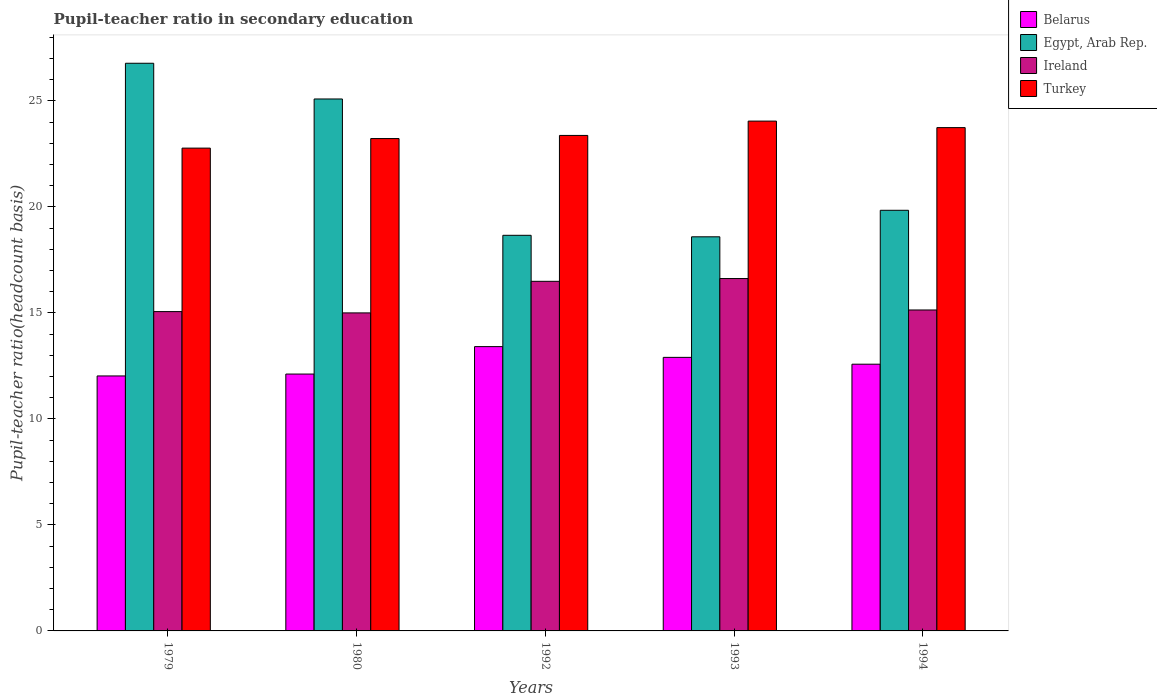How many different coloured bars are there?
Keep it short and to the point. 4. Are the number of bars per tick equal to the number of legend labels?
Your answer should be compact. Yes. Are the number of bars on each tick of the X-axis equal?
Your answer should be compact. Yes. How many bars are there on the 4th tick from the left?
Offer a very short reply. 4. How many bars are there on the 5th tick from the right?
Your response must be concise. 4. What is the label of the 1st group of bars from the left?
Provide a succinct answer. 1979. In how many cases, is the number of bars for a given year not equal to the number of legend labels?
Make the answer very short. 0. What is the pupil-teacher ratio in secondary education in Belarus in 1980?
Make the answer very short. 12.12. Across all years, what is the maximum pupil-teacher ratio in secondary education in Egypt, Arab Rep.?
Give a very brief answer. 26.78. Across all years, what is the minimum pupil-teacher ratio in secondary education in Belarus?
Offer a terse response. 12.03. In which year was the pupil-teacher ratio in secondary education in Turkey maximum?
Provide a short and direct response. 1993. In which year was the pupil-teacher ratio in secondary education in Belarus minimum?
Your answer should be very brief. 1979. What is the total pupil-teacher ratio in secondary education in Ireland in the graph?
Keep it short and to the point. 78.31. What is the difference between the pupil-teacher ratio in secondary education in Belarus in 1979 and that in 1994?
Offer a terse response. -0.55. What is the difference between the pupil-teacher ratio in secondary education in Belarus in 1992 and the pupil-teacher ratio in secondary education in Turkey in 1994?
Provide a succinct answer. -10.33. What is the average pupil-teacher ratio in secondary education in Ireland per year?
Provide a short and direct response. 15.66. In the year 1993, what is the difference between the pupil-teacher ratio in secondary education in Ireland and pupil-teacher ratio in secondary education in Belarus?
Give a very brief answer. 3.72. What is the ratio of the pupil-teacher ratio in secondary education in Ireland in 1979 to that in 1994?
Give a very brief answer. 0.99. Is the pupil-teacher ratio in secondary education in Belarus in 1980 less than that in 1994?
Keep it short and to the point. Yes. Is the difference between the pupil-teacher ratio in secondary education in Ireland in 1979 and 1992 greater than the difference between the pupil-teacher ratio in secondary education in Belarus in 1979 and 1992?
Your answer should be compact. No. What is the difference between the highest and the second highest pupil-teacher ratio in secondary education in Belarus?
Your answer should be compact. 0.51. What is the difference between the highest and the lowest pupil-teacher ratio in secondary education in Turkey?
Your answer should be compact. 1.27. Is it the case that in every year, the sum of the pupil-teacher ratio in secondary education in Belarus and pupil-teacher ratio in secondary education in Ireland is greater than the sum of pupil-teacher ratio in secondary education in Turkey and pupil-teacher ratio in secondary education in Egypt, Arab Rep.?
Give a very brief answer. Yes. What does the 2nd bar from the left in 1993 represents?
Provide a succinct answer. Egypt, Arab Rep. What does the 4th bar from the right in 1980 represents?
Provide a succinct answer. Belarus. How many bars are there?
Your response must be concise. 20. How many years are there in the graph?
Ensure brevity in your answer.  5. What is the difference between two consecutive major ticks on the Y-axis?
Your answer should be compact. 5. Does the graph contain any zero values?
Provide a succinct answer. No. Does the graph contain grids?
Your answer should be compact. No. Where does the legend appear in the graph?
Offer a very short reply. Top right. How many legend labels are there?
Ensure brevity in your answer.  4. How are the legend labels stacked?
Your answer should be compact. Vertical. What is the title of the graph?
Offer a very short reply. Pupil-teacher ratio in secondary education. Does "St. Martin (French part)" appear as one of the legend labels in the graph?
Offer a very short reply. No. What is the label or title of the Y-axis?
Your answer should be compact. Pupil-teacher ratio(headcount basis). What is the Pupil-teacher ratio(headcount basis) of Belarus in 1979?
Ensure brevity in your answer.  12.03. What is the Pupil-teacher ratio(headcount basis) of Egypt, Arab Rep. in 1979?
Make the answer very short. 26.78. What is the Pupil-teacher ratio(headcount basis) in Ireland in 1979?
Give a very brief answer. 15.06. What is the Pupil-teacher ratio(headcount basis) of Turkey in 1979?
Provide a short and direct response. 22.77. What is the Pupil-teacher ratio(headcount basis) in Belarus in 1980?
Your answer should be very brief. 12.12. What is the Pupil-teacher ratio(headcount basis) in Egypt, Arab Rep. in 1980?
Provide a short and direct response. 25.09. What is the Pupil-teacher ratio(headcount basis) in Ireland in 1980?
Your response must be concise. 15. What is the Pupil-teacher ratio(headcount basis) in Turkey in 1980?
Give a very brief answer. 23.22. What is the Pupil-teacher ratio(headcount basis) in Belarus in 1992?
Provide a succinct answer. 13.41. What is the Pupil-teacher ratio(headcount basis) of Egypt, Arab Rep. in 1992?
Offer a very short reply. 18.66. What is the Pupil-teacher ratio(headcount basis) in Ireland in 1992?
Your answer should be very brief. 16.49. What is the Pupil-teacher ratio(headcount basis) in Turkey in 1992?
Keep it short and to the point. 23.37. What is the Pupil-teacher ratio(headcount basis) in Belarus in 1993?
Make the answer very short. 12.9. What is the Pupil-teacher ratio(headcount basis) of Egypt, Arab Rep. in 1993?
Offer a terse response. 18.59. What is the Pupil-teacher ratio(headcount basis) of Ireland in 1993?
Provide a short and direct response. 16.62. What is the Pupil-teacher ratio(headcount basis) in Turkey in 1993?
Ensure brevity in your answer.  24.05. What is the Pupil-teacher ratio(headcount basis) in Belarus in 1994?
Your answer should be very brief. 12.58. What is the Pupil-teacher ratio(headcount basis) of Egypt, Arab Rep. in 1994?
Your answer should be very brief. 19.84. What is the Pupil-teacher ratio(headcount basis) in Ireland in 1994?
Provide a succinct answer. 15.14. What is the Pupil-teacher ratio(headcount basis) in Turkey in 1994?
Your answer should be compact. 23.74. Across all years, what is the maximum Pupil-teacher ratio(headcount basis) of Belarus?
Your response must be concise. 13.41. Across all years, what is the maximum Pupil-teacher ratio(headcount basis) in Egypt, Arab Rep.?
Offer a terse response. 26.78. Across all years, what is the maximum Pupil-teacher ratio(headcount basis) of Ireland?
Offer a very short reply. 16.62. Across all years, what is the maximum Pupil-teacher ratio(headcount basis) of Turkey?
Your response must be concise. 24.05. Across all years, what is the minimum Pupil-teacher ratio(headcount basis) of Belarus?
Offer a very short reply. 12.03. Across all years, what is the minimum Pupil-teacher ratio(headcount basis) of Egypt, Arab Rep.?
Offer a very short reply. 18.59. Across all years, what is the minimum Pupil-teacher ratio(headcount basis) of Ireland?
Make the answer very short. 15. Across all years, what is the minimum Pupil-teacher ratio(headcount basis) in Turkey?
Your answer should be very brief. 22.77. What is the total Pupil-teacher ratio(headcount basis) of Belarus in the graph?
Make the answer very short. 63.04. What is the total Pupil-teacher ratio(headcount basis) of Egypt, Arab Rep. in the graph?
Keep it short and to the point. 108.96. What is the total Pupil-teacher ratio(headcount basis) in Ireland in the graph?
Your response must be concise. 78.31. What is the total Pupil-teacher ratio(headcount basis) of Turkey in the graph?
Keep it short and to the point. 117.16. What is the difference between the Pupil-teacher ratio(headcount basis) of Belarus in 1979 and that in 1980?
Your answer should be compact. -0.09. What is the difference between the Pupil-teacher ratio(headcount basis) in Egypt, Arab Rep. in 1979 and that in 1980?
Your response must be concise. 1.68. What is the difference between the Pupil-teacher ratio(headcount basis) in Ireland in 1979 and that in 1980?
Provide a succinct answer. 0.06. What is the difference between the Pupil-teacher ratio(headcount basis) of Turkey in 1979 and that in 1980?
Ensure brevity in your answer.  -0.45. What is the difference between the Pupil-teacher ratio(headcount basis) in Belarus in 1979 and that in 1992?
Offer a very short reply. -1.38. What is the difference between the Pupil-teacher ratio(headcount basis) in Egypt, Arab Rep. in 1979 and that in 1992?
Provide a short and direct response. 8.12. What is the difference between the Pupil-teacher ratio(headcount basis) in Ireland in 1979 and that in 1992?
Your answer should be compact. -1.43. What is the difference between the Pupil-teacher ratio(headcount basis) in Turkey in 1979 and that in 1992?
Provide a succinct answer. -0.6. What is the difference between the Pupil-teacher ratio(headcount basis) of Belarus in 1979 and that in 1993?
Ensure brevity in your answer.  -0.88. What is the difference between the Pupil-teacher ratio(headcount basis) in Egypt, Arab Rep. in 1979 and that in 1993?
Your response must be concise. 8.19. What is the difference between the Pupil-teacher ratio(headcount basis) of Ireland in 1979 and that in 1993?
Make the answer very short. -1.56. What is the difference between the Pupil-teacher ratio(headcount basis) of Turkey in 1979 and that in 1993?
Your response must be concise. -1.27. What is the difference between the Pupil-teacher ratio(headcount basis) in Belarus in 1979 and that in 1994?
Your answer should be very brief. -0.55. What is the difference between the Pupil-teacher ratio(headcount basis) in Egypt, Arab Rep. in 1979 and that in 1994?
Offer a very short reply. 6.94. What is the difference between the Pupil-teacher ratio(headcount basis) in Ireland in 1979 and that in 1994?
Give a very brief answer. -0.08. What is the difference between the Pupil-teacher ratio(headcount basis) of Turkey in 1979 and that in 1994?
Your response must be concise. -0.97. What is the difference between the Pupil-teacher ratio(headcount basis) of Belarus in 1980 and that in 1992?
Provide a succinct answer. -1.29. What is the difference between the Pupil-teacher ratio(headcount basis) in Egypt, Arab Rep. in 1980 and that in 1992?
Give a very brief answer. 6.43. What is the difference between the Pupil-teacher ratio(headcount basis) in Ireland in 1980 and that in 1992?
Provide a succinct answer. -1.49. What is the difference between the Pupil-teacher ratio(headcount basis) of Turkey in 1980 and that in 1992?
Your answer should be very brief. -0.15. What is the difference between the Pupil-teacher ratio(headcount basis) in Belarus in 1980 and that in 1993?
Provide a succinct answer. -0.79. What is the difference between the Pupil-teacher ratio(headcount basis) of Egypt, Arab Rep. in 1980 and that in 1993?
Your answer should be compact. 6.5. What is the difference between the Pupil-teacher ratio(headcount basis) in Ireland in 1980 and that in 1993?
Make the answer very short. -1.62. What is the difference between the Pupil-teacher ratio(headcount basis) of Turkey in 1980 and that in 1993?
Your response must be concise. -0.82. What is the difference between the Pupil-teacher ratio(headcount basis) of Belarus in 1980 and that in 1994?
Offer a terse response. -0.47. What is the difference between the Pupil-teacher ratio(headcount basis) in Egypt, Arab Rep. in 1980 and that in 1994?
Provide a short and direct response. 5.25. What is the difference between the Pupil-teacher ratio(headcount basis) of Ireland in 1980 and that in 1994?
Give a very brief answer. -0.14. What is the difference between the Pupil-teacher ratio(headcount basis) in Turkey in 1980 and that in 1994?
Provide a succinct answer. -0.52. What is the difference between the Pupil-teacher ratio(headcount basis) of Belarus in 1992 and that in 1993?
Provide a short and direct response. 0.51. What is the difference between the Pupil-teacher ratio(headcount basis) in Egypt, Arab Rep. in 1992 and that in 1993?
Offer a very short reply. 0.07. What is the difference between the Pupil-teacher ratio(headcount basis) of Ireland in 1992 and that in 1993?
Offer a terse response. -0.13. What is the difference between the Pupil-teacher ratio(headcount basis) in Turkey in 1992 and that in 1993?
Your response must be concise. -0.68. What is the difference between the Pupil-teacher ratio(headcount basis) of Belarus in 1992 and that in 1994?
Your answer should be compact. 0.83. What is the difference between the Pupil-teacher ratio(headcount basis) in Egypt, Arab Rep. in 1992 and that in 1994?
Your response must be concise. -1.18. What is the difference between the Pupil-teacher ratio(headcount basis) of Ireland in 1992 and that in 1994?
Provide a short and direct response. 1.35. What is the difference between the Pupil-teacher ratio(headcount basis) of Turkey in 1992 and that in 1994?
Provide a short and direct response. -0.37. What is the difference between the Pupil-teacher ratio(headcount basis) of Belarus in 1993 and that in 1994?
Ensure brevity in your answer.  0.32. What is the difference between the Pupil-teacher ratio(headcount basis) of Egypt, Arab Rep. in 1993 and that in 1994?
Your answer should be compact. -1.25. What is the difference between the Pupil-teacher ratio(headcount basis) of Ireland in 1993 and that in 1994?
Your answer should be very brief. 1.48. What is the difference between the Pupil-teacher ratio(headcount basis) of Turkey in 1993 and that in 1994?
Ensure brevity in your answer.  0.31. What is the difference between the Pupil-teacher ratio(headcount basis) in Belarus in 1979 and the Pupil-teacher ratio(headcount basis) in Egypt, Arab Rep. in 1980?
Provide a short and direct response. -13.06. What is the difference between the Pupil-teacher ratio(headcount basis) in Belarus in 1979 and the Pupil-teacher ratio(headcount basis) in Ireland in 1980?
Offer a terse response. -2.97. What is the difference between the Pupil-teacher ratio(headcount basis) of Belarus in 1979 and the Pupil-teacher ratio(headcount basis) of Turkey in 1980?
Your answer should be compact. -11.2. What is the difference between the Pupil-teacher ratio(headcount basis) of Egypt, Arab Rep. in 1979 and the Pupil-teacher ratio(headcount basis) of Ireland in 1980?
Offer a very short reply. 11.78. What is the difference between the Pupil-teacher ratio(headcount basis) in Egypt, Arab Rep. in 1979 and the Pupil-teacher ratio(headcount basis) in Turkey in 1980?
Give a very brief answer. 3.55. What is the difference between the Pupil-teacher ratio(headcount basis) of Ireland in 1979 and the Pupil-teacher ratio(headcount basis) of Turkey in 1980?
Your answer should be very brief. -8.16. What is the difference between the Pupil-teacher ratio(headcount basis) of Belarus in 1979 and the Pupil-teacher ratio(headcount basis) of Egypt, Arab Rep. in 1992?
Your answer should be very brief. -6.63. What is the difference between the Pupil-teacher ratio(headcount basis) in Belarus in 1979 and the Pupil-teacher ratio(headcount basis) in Ireland in 1992?
Your response must be concise. -4.46. What is the difference between the Pupil-teacher ratio(headcount basis) in Belarus in 1979 and the Pupil-teacher ratio(headcount basis) in Turkey in 1992?
Your answer should be compact. -11.34. What is the difference between the Pupil-teacher ratio(headcount basis) of Egypt, Arab Rep. in 1979 and the Pupil-teacher ratio(headcount basis) of Ireland in 1992?
Your answer should be very brief. 10.29. What is the difference between the Pupil-teacher ratio(headcount basis) of Egypt, Arab Rep. in 1979 and the Pupil-teacher ratio(headcount basis) of Turkey in 1992?
Make the answer very short. 3.4. What is the difference between the Pupil-teacher ratio(headcount basis) of Ireland in 1979 and the Pupil-teacher ratio(headcount basis) of Turkey in 1992?
Provide a short and direct response. -8.31. What is the difference between the Pupil-teacher ratio(headcount basis) of Belarus in 1979 and the Pupil-teacher ratio(headcount basis) of Egypt, Arab Rep. in 1993?
Provide a short and direct response. -6.56. What is the difference between the Pupil-teacher ratio(headcount basis) in Belarus in 1979 and the Pupil-teacher ratio(headcount basis) in Ireland in 1993?
Provide a succinct answer. -4.59. What is the difference between the Pupil-teacher ratio(headcount basis) of Belarus in 1979 and the Pupil-teacher ratio(headcount basis) of Turkey in 1993?
Provide a short and direct response. -12.02. What is the difference between the Pupil-teacher ratio(headcount basis) of Egypt, Arab Rep. in 1979 and the Pupil-teacher ratio(headcount basis) of Ireland in 1993?
Ensure brevity in your answer.  10.15. What is the difference between the Pupil-teacher ratio(headcount basis) of Egypt, Arab Rep. in 1979 and the Pupil-teacher ratio(headcount basis) of Turkey in 1993?
Offer a very short reply. 2.73. What is the difference between the Pupil-teacher ratio(headcount basis) in Ireland in 1979 and the Pupil-teacher ratio(headcount basis) in Turkey in 1993?
Your response must be concise. -8.99. What is the difference between the Pupil-teacher ratio(headcount basis) in Belarus in 1979 and the Pupil-teacher ratio(headcount basis) in Egypt, Arab Rep. in 1994?
Offer a terse response. -7.81. What is the difference between the Pupil-teacher ratio(headcount basis) of Belarus in 1979 and the Pupil-teacher ratio(headcount basis) of Ireland in 1994?
Offer a very short reply. -3.11. What is the difference between the Pupil-teacher ratio(headcount basis) in Belarus in 1979 and the Pupil-teacher ratio(headcount basis) in Turkey in 1994?
Provide a succinct answer. -11.71. What is the difference between the Pupil-teacher ratio(headcount basis) of Egypt, Arab Rep. in 1979 and the Pupil-teacher ratio(headcount basis) of Ireland in 1994?
Make the answer very short. 11.64. What is the difference between the Pupil-teacher ratio(headcount basis) in Egypt, Arab Rep. in 1979 and the Pupil-teacher ratio(headcount basis) in Turkey in 1994?
Give a very brief answer. 3.04. What is the difference between the Pupil-teacher ratio(headcount basis) of Ireland in 1979 and the Pupil-teacher ratio(headcount basis) of Turkey in 1994?
Provide a succinct answer. -8.68. What is the difference between the Pupil-teacher ratio(headcount basis) of Belarus in 1980 and the Pupil-teacher ratio(headcount basis) of Egypt, Arab Rep. in 1992?
Provide a short and direct response. -6.54. What is the difference between the Pupil-teacher ratio(headcount basis) of Belarus in 1980 and the Pupil-teacher ratio(headcount basis) of Ireland in 1992?
Offer a very short reply. -4.37. What is the difference between the Pupil-teacher ratio(headcount basis) in Belarus in 1980 and the Pupil-teacher ratio(headcount basis) in Turkey in 1992?
Provide a short and direct response. -11.26. What is the difference between the Pupil-teacher ratio(headcount basis) in Egypt, Arab Rep. in 1980 and the Pupil-teacher ratio(headcount basis) in Ireland in 1992?
Provide a short and direct response. 8.6. What is the difference between the Pupil-teacher ratio(headcount basis) in Egypt, Arab Rep. in 1980 and the Pupil-teacher ratio(headcount basis) in Turkey in 1992?
Ensure brevity in your answer.  1.72. What is the difference between the Pupil-teacher ratio(headcount basis) in Ireland in 1980 and the Pupil-teacher ratio(headcount basis) in Turkey in 1992?
Offer a terse response. -8.37. What is the difference between the Pupil-teacher ratio(headcount basis) in Belarus in 1980 and the Pupil-teacher ratio(headcount basis) in Egypt, Arab Rep. in 1993?
Offer a terse response. -6.47. What is the difference between the Pupil-teacher ratio(headcount basis) in Belarus in 1980 and the Pupil-teacher ratio(headcount basis) in Ireland in 1993?
Make the answer very short. -4.51. What is the difference between the Pupil-teacher ratio(headcount basis) of Belarus in 1980 and the Pupil-teacher ratio(headcount basis) of Turkey in 1993?
Give a very brief answer. -11.93. What is the difference between the Pupil-teacher ratio(headcount basis) in Egypt, Arab Rep. in 1980 and the Pupil-teacher ratio(headcount basis) in Ireland in 1993?
Ensure brevity in your answer.  8.47. What is the difference between the Pupil-teacher ratio(headcount basis) in Egypt, Arab Rep. in 1980 and the Pupil-teacher ratio(headcount basis) in Turkey in 1993?
Keep it short and to the point. 1.04. What is the difference between the Pupil-teacher ratio(headcount basis) in Ireland in 1980 and the Pupil-teacher ratio(headcount basis) in Turkey in 1993?
Make the answer very short. -9.05. What is the difference between the Pupil-teacher ratio(headcount basis) in Belarus in 1980 and the Pupil-teacher ratio(headcount basis) in Egypt, Arab Rep. in 1994?
Your response must be concise. -7.72. What is the difference between the Pupil-teacher ratio(headcount basis) of Belarus in 1980 and the Pupil-teacher ratio(headcount basis) of Ireland in 1994?
Offer a very short reply. -3.02. What is the difference between the Pupil-teacher ratio(headcount basis) in Belarus in 1980 and the Pupil-teacher ratio(headcount basis) in Turkey in 1994?
Your response must be concise. -11.62. What is the difference between the Pupil-teacher ratio(headcount basis) in Egypt, Arab Rep. in 1980 and the Pupil-teacher ratio(headcount basis) in Ireland in 1994?
Make the answer very short. 9.95. What is the difference between the Pupil-teacher ratio(headcount basis) of Egypt, Arab Rep. in 1980 and the Pupil-teacher ratio(headcount basis) of Turkey in 1994?
Make the answer very short. 1.35. What is the difference between the Pupil-teacher ratio(headcount basis) in Ireland in 1980 and the Pupil-teacher ratio(headcount basis) in Turkey in 1994?
Make the answer very short. -8.74. What is the difference between the Pupil-teacher ratio(headcount basis) of Belarus in 1992 and the Pupil-teacher ratio(headcount basis) of Egypt, Arab Rep. in 1993?
Your answer should be very brief. -5.18. What is the difference between the Pupil-teacher ratio(headcount basis) of Belarus in 1992 and the Pupil-teacher ratio(headcount basis) of Ireland in 1993?
Make the answer very short. -3.21. What is the difference between the Pupil-teacher ratio(headcount basis) in Belarus in 1992 and the Pupil-teacher ratio(headcount basis) in Turkey in 1993?
Offer a terse response. -10.64. What is the difference between the Pupil-teacher ratio(headcount basis) of Egypt, Arab Rep. in 1992 and the Pupil-teacher ratio(headcount basis) of Ireland in 1993?
Make the answer very short. 2.04. What is the difference between the Pupil-teacher ratio(headcount basis) in Egypt, Arab Rep. in 1992 and the Pupil-teacher ratio(headcount basis) in Turkey in 1993?
Provide a succinct answer. -5.39. What is the difference between the Pupil-teacher ratio(headcount basis) in Ireland in 1992 and the Pupil-teacher ratio(headcount basis) in Turkey in 1993?
Keep it short and to the point. -7.56. What is the difference between the Pupil-teacher ratio(headcount basis) of Belarus in 1992 and the Pupil-teacher ratio(headcount basis) of Egypt, Arab Rep. in 1994?
Your answer should be compact. -6.43. What is the difference between the Pupil-teacher ratio(headcount basis) of Belarus in 1992 and the Pupil-teacher ratio(headcount basis) of Ireland in 1994?
Your response must be concise. -1.73. What is the difference between the Pupil-teacher ratio(headcount basis) in Belarus in 1992 and the Pupil-teacher ratio(headcount basis) in Turkey in 1994?
Your answer should be compact. -10.33. What is the difference between the Pupil-teacher ratio(headcount basis) in Egypt, Arab Rep. in 1992 and the Pupil-teacher ratio(headcount basis) in Ireland in 1994?
Your answer should be very brief. 3.52. What is the difference between the Pupil-teacher ratio(headcount basis) of Egypt, Arab Rep. in 1992 and the Pupil-teacher ratio(headcount basis) of Turkey in 1994?
Keep it short and to the point. -5.08. What is the difference between the Pupil-teacher ratio(headcount basis) of Ireland in 1992 and the Pupil-teacher ratio(headcount basis) of Turkey in 1994?
Ensure brevity in your answer.  -7.25. What is the difference between the Pupil-teacher ratio(headcount basis) in Belarus in 1993 and the Pupil-teacher ratio(headcount basis) in Egypt, Arab Rep. in 1994?
Give a very brief answer. -6.94. What is the difference between the Pupil-teacher ratio(headcount basis) in Belarus in 1993 and the Pupil-teacher ratio(headcount basis) in Ireland in 1994?
Offer a very short reply. -2.24. What is the difference between the Pupil-teacher ratio(headcount basis) in Belarus in 1993 and the Pupil-teacher ratio(headcount basis) in Turkey in 1994?
Offer a very short reply. -10.84. What is the difference between the Pupil-teacher ratio(headcount basis) of Egypt, Arab Rep. in 1993 and the Pupil-teacher ratio(headcount basis) of Ireland in 1994?
Ensure brevity in your answer.  3.45. What is the difference between the Pupil-teacher ratio(headcount basis) of Egypt, Arab Rep. in 1993 and the Pupil-teacher ratio(headcount basis) of Turkey in 1994?
Offer a very short reply. -5.15. What is the difference between the Pupil-teacher ratio(headcount basis) in Ireland in 1993 and the Pupil-teacher ratio(headcount basis) in Turkey in 1994?
Provide a succinct answer. -7.12. What is the average Pupil-teacher ratio(headcount basis) of Belarus per year?
Ensure brevity in your answer.  12.61. What is the average Pupil-teacher ratio(headcount basis) of Egypt, Arab Rep. per year?
Provide a succinct answer. 21.79. What is the average Pupil-teacher ratio(headcount basis) in Ireland per year?
Ensure brevity in your answer.  15.66. What is the average Pupil-teacher ratio(headcount basis) of Turkey per year?
Offer a very short reply. 23.43. In the year 1979, what is the difference between the Pupil-teacher ratio(headcount basis) of Belarus and Pupil-teacher ratio(headcount basis) of Egypt, Arab Rep.?
Your answer should be very brief. -14.75. In the year 1979, what is the difference between the Pupil-teacher ratio(headcount basis) in Belarus and Pupil-teacher ratio(headcount basis) in Ireland?
Your response must be concise. -3.04. In the year 1979, what is the difference between the Pupil-teacher ratio(headcount basis) in Belarus and Pupil-teacher ratio(headcount basis) in Turkey?
Provide a short and direct response. -10.75. In the year 1979, what is the difference between the Pupil-teacher ratio(headcount basis) of Egypt, Arab Rep. and Pupil-teacher ratio(headcount basis) of Ireland?
Your response must be concise. 11.71. In the year 1979, what is the difference between the Pupil-teacher ratio(headcount basis) in Egypt, Arab Rep. and Pupil-teacher ratio(headcount basis) in Turkey?
Your answer should be very brief. 4. In the year 1979, what is the difference between the Pupil-teacher ratio(headcount basis) of Ireland and Pupil-teacher ratio(headcount basis) of Turkey?
Ensure brevity in your answer.  -7.71. In the year 1980, what is the difference between the Pupil-teacher ratio(headcount basis) in Belarus and Pupil-teacher ratio(headcount basis) in Egypt, Arab Rep.?
Your answer should be compact. -12.98. In the year 1980, what is the difference between the Pupil-teacher ratio(headcount basis) of Belarus and Pupil-teacher ratio(headcount basis) of Ireland?
Offer a terse response. -2.89. In the year 1980, what is the difference between the Pupil-teacher ratio(headcount basis) of Belarus and Pupil-teacher ratio(headcount basis) of Turkey?
Give a very brief answer. -11.11. In the year 1980, what is the difference between the Pupil-teacher ratio(headcount basis) of Egypt, Arab Rep. and Pupil-teacher ratio(headcount basis) of Ireland?
Your answer should be very brief. 10.09. In the year 1980, what is the difference between the Pupil-teacher ratio(headcount basis) in Egypt, Arab Rep. and Pupil-teacher ratio(headcount basis) in Turkey?
Your response must be concise. 1.87. In the year 1980, what is the difference between the Pupil-teacher ratio(headcount basis) of Ireland and Pupil-teacher ratio(headcount basis) of Turkey?
Make the answer very short. -8.22. In the year 1992, what is the difference between the Pupil-teacher ratio(headcount basis) of Belarus and Pupil-teacher ratio(headcount basis) of Egypt, Arab Rep.?
Keep it short and to the point. -5.25. In the year 1992, what is the difference between the Pupil-teacher ratio(headcount basis) of Belarus and Pupil-teacher ratio(headcount basis) of Ireland?
Give a very brief answer. -3.08. In the year 1992, what is the difference between the Pupil-teacher ratio(headcount basis) of Belarus and Pupil-teacher ratio(headcount basis) of Turkey?
Make the answer very short. -9.96. In the year 1992, what is the difference between the Pupil-teacher ratio(headcount basis) of Egypt, Arab Rep. and Pupil-teacher ratio(headcount basis) of Ireland?
Ensure brevity in your answer.  2.17. In the year 1992, what is the difference between the Pupil-teacher ratio(headcount basis) of Egypt, Arab Rep. and Pupil-teacher ratio(headcount basis) of Turkey?
Keep it short and to the point. -4.71. In the year 1992, what is the difference between the Pupil-teacher ratio(headcount basis) of Ireland and Pupil-teacher ratio(headcount basis) of Turkey?
Your answer should be compact. -6.88. In the year 1993, what is the difference between the Pupil-teacher ratio(headcount basis) of Belarus and Pupil-teacher ratio(headcount basis) of Egypt, Arab Rep.?
Your answer should be very brief. -5.69. In the year 1993, what is the difference between the Pupil-teacher ratio(headcount basis) in Belarus and Pupil-teacher ratio(headcount basis) in Ireland?
Provide a succinct answer. -3.72. In the year 1993, what is the difference between the Pupil-teacher ratio(headcount basis) in Belarus and Pupil-teacher ratio(headcount basis) in Turkey?
Your answer should be compact. -11.14. In the year 1993, what is the difference between the Pupil-teacher ratio(headcount basis) in Egypt, Arab Rep. and Pupil-teacher ratio(headcount basis) in Ireland?
Give a very brief answer. 1.97. In the year 1993, what is the difference between the Pupil-teacher ratio(headcount basis) of Egypt, Arab Rep. and Pupil-teacher ratio(headcount basis) of Turkey?
Your answer should be compact. -5.46. In the year 1993, what is the difference between the Pupil-teacher ratio(headcount basis) of Ireland and Pupil-teacher ratio(headcount basis) of Turkey?
Offer a very short reply. -7.43. In the year 1994, what is the difference between the Pupil-teacher ratio(headcount basis) of Belarus and Pupil-teacher ratio(headcount basis) of Egypt, Arab Rep.?
Offer a terse response. -7.26. In the year 1994, what is the difference between the Pupil-teacher ratio(headcount basis) of Belarus and Pupil-teacher ratio(headcount basis) of Ireland?
Make the answer very short. -2.56. In the year 1994, what is the difference between the Pupil-teacher ratio(headcount basis) of Belarus and Pupil-teacher ratio(headcount basis) of Turkey?
Provide a succinct answer. -11.16. In the year 1994, what is the difference between the Pupil-teacher ratio(headcount basis) in Egypt, Arab Rep. and Pupil-teacher ratio(headcount basis) in Ireland?
Keep it short and to the point. 4.7. In the year 1994, what is the difference between the Pupil-teacher ratio(headcount basis) of Egypt, Arab Rep. and Pupil-teacher ratio(headcount basis) of Turkey?
Your answer should be compact. -3.9. In the year 1994, what is the difference between the Pupil-teacher ratio(headcount basis) of Ireland and Pupil-teacher ratio(headcount basis) of Turkey?
Keep it short and to the point. -8.6. What is the ratio of the Pupil-teacher ratio(headcount basis) in Belarus in 1979 to that in 1980?
Your response must be concise. 0.99. What is the ratio of the Pupil-teacher ratio(headcount basis) of Egypt, Arab Rep. in 1979 to that in 1980?
Ensure brevity in your answer.  1.07. What is the ratio of the Pupil-teacher ratio(headcount basis) in Ireland in 1979 to that in 1980?
Keep it short and to the point. 1. What is the ratio of the Pupil-teacher ratio(headcount basis) of Turkey in 1979 to that in 1980?
Offer a very short reply. 0.98. What is the ratio of the Pupil-teacher ratio(headcount basis) of Belarus in 1979 to that in 1992?
Ensure brevity in your answer.  0.9. What is the ratio of the Pupil-teacher ratio(headcount basis) in Egypt, Arab Rep. in 1979 to that in 1992?
Keep it short and to the point. 1.43. What is the ratio of the Pupil-teacher ratio(headcount basis) in Ireland in 1979 to that in 1992?
Provide a succinct answer. 0.91. What is the ratio of the Pupil-teacher ratio(headcount basis) of Turkey in 1979 to that in 1992?
Ensure brevity in your answer.  0.97. What is the ratio of the Pupil-teacher ratio(headcount basis) in Belarus in 1979 to that in 1993?
Provide a succinct answer. 0.93. What is the ratio of the Pupil-teacher ratio(headcount basis) of Egypt, Arab Rep. in 1979 to that in 1993?
Ensure brevity in your answer.  1.44. What is the ratio of the Pupil-teacher ratio(headcount basis) of Ireland in 1979 to that in 1993?
Ensure brevity in your answer.  0.91. What is the ratio of the Pupil-teacher ratio(headcount basis) in Turkey in 1979 to that in 1993?
Ensure brevity in your answer.  0.95. What is the ratio of the Pupil-teacher ratio(headcount basis) of Belarus in 1979 to that in 1994?
Offer a terse response. 0.96. What is the ratio of the Pupil-teacher ratio(headcount basis) in Egypt, Arab Rep. in 1979 to that in 1994?
Your answer should be compact. 1.35. What is the ratio of the Pupil-teacher ratio(headcount basis) in Ireland in 1979 to that in 1994?
Offer a very short reply. 0.99. What is the ratio of the Pupil-teacher ratio(headcount basis) in Turkey in 1979 to that in 1994?
Your answer should be very brief. 0.96. What is the ratio of the Pupil-teacher ratio(headcount basis) in Belarus in 1980 to that in 1992?
Your answer should be compact. 0.9. What is the ratio of the Pupil-teacher ratio(headcount basis) of Egypt, Arab Rep. in 1980 to that in 1992?
Offer a very short reply. 1.34. What is the ratio of the Pupil-teacher ratio(headcount basis) in Ireland in 1980 to that in 1992?
Offer a very short reply. 0.91. What is the ratio of the Pupil-teacher ratio(headcount basis) in Turkey in 1980 to that in 1992?
Offer a terse response. 0.99. What is the ratio of the Pupil-teacher ratio(headcount basis) of Belarus in 1980 to that in 1993?
Your answer should be compact. 0.94. What is the ratio of the Pupil-teacher ratio(headcount basis) of Egypt, Arab Rep. in 1980 to that in 1993?
Your answer should be very brief. 1.35. What is the ratio of the Pupil-teacher ratio(headcount basis) in Ireland in 1980 to that in 1993?
Make the answer very short. 0.9. What is the ratio of the Pupil-teacher ratio(headcount basis) in Turkey in 1980 to that in 1993?
Your response must be concise. 0.97. What is the ratio of the Pupil-teacher ratio(headcount basis) in Belarus in 1980 to that in 1994?
Offer a very short reply. 0.96. What is the ratio of the Pupil-teacher ratio(headcount basis) in Egypt, Arab Rep. in 1980 to that in 1994?
Make the answer very short. 1.26. What is the ratio of the Pupil-teacher ratio(headcount basis) of Ireland in 1980 to that in 1994?
Offer a very short reply. 0.99. What is the ratio of the Pupil-teacher ratio(headcount basis) of Turkey in 1980 to that in 1994?
Your response must be concise. 0.98. What is the ratio of the Pupil-teacher ratio(headcount basis) of Belarus in 1992 to that in 1993?
Provide a short and direct response. 1.04. What is the ratio of the Pupil-teacher ratio(headcount basis) in Ireland in 1992 to that in 1993?
Give a very brief answer. 0.99. What is the ratio of the Pupil-teacher ratio(headcount basis) in Turkey in 1992 to that in 1993?
Provide a succinct answer. 0.97. What is the ratio of the Pupil-teacher ratio(headcount basis) of Belarus in 1992 to that in 1994?
Offer a very short reply. 1.07. What is the ratio of the Pupil-teacher ratio(headcount basis) of Egypt, Arab Rep. in 1992 to that in 1994?
Keep it short and to the point. 0.94. What is the ratio of the Pupil-teacher ratio(headcount basis) of Ireland in 1992 to that in 1994?
Your answer should be very brief. 1.09. What is the ratio of the Pupil-teacher ratio(headcount basis) of Turkey in 1992 to that in 1994?
Your answer should be compact. 0.98. What is the ratio of the Pupil-teacher ratio(headcount basis) of Belarus in 1993 to that in 1994?
Make the answer very short. 1.03. What is the ratio of the Pupil-teacher ratio(headcount basis) in Egypt, Arab Rep. in 1993 to that in 1994?
Provide a short and direct response. 0.94. What is the ratio of the Pupil-teacher ratio(headcount basis) in Ireland in 1993 to that in 1994?
Offer a very short reply. 1.1. What is the ratio of the Pupil-teacher ratio(headcount basis) in Turkey in 1993 to that in 1994?
Offer a terse response. 1.01. What is the difference between the highest and the second highest Pupil-teacher ratio(headcount basis) in Belarus?
Your answer should be compact. 0.51. What is the difference between the highest and the second highest Pupil-teacher ratio(headcount basis) of Egypt, Arab Rep.?
Ensure brevity in your answer.  1.68. What is the difference between the highest and the second highest Pupil-teacher ratio(headcount basis) of Ireland?
Your answer should be very brief. 0.13. What is the difference between the highest and the second highest Pupil-teacher ratio(headcount basis) in Turkey?
Your answer should be compact. 0.31. What is the difference between the highest and the lowest Pupil-teacher ratio(headcount basis) in Belarus?
Provide a succinct answer. 1.38. What is the difference between the highest and the lowest Pupil-teacher ratio(headcount basis) of Egypt, Arab Rep.?
Your answer should be very brief. 8.19. What is the difference between the highest and the lowest Pupil-teacher ratio(headcount basis) in Ireland?
Give a very brief answer. 1.62. What is the difference between the highest and the lowest Pupil-teacher ratio(headcount basis) in Turkey?
Your response must be concise. 1.27. 